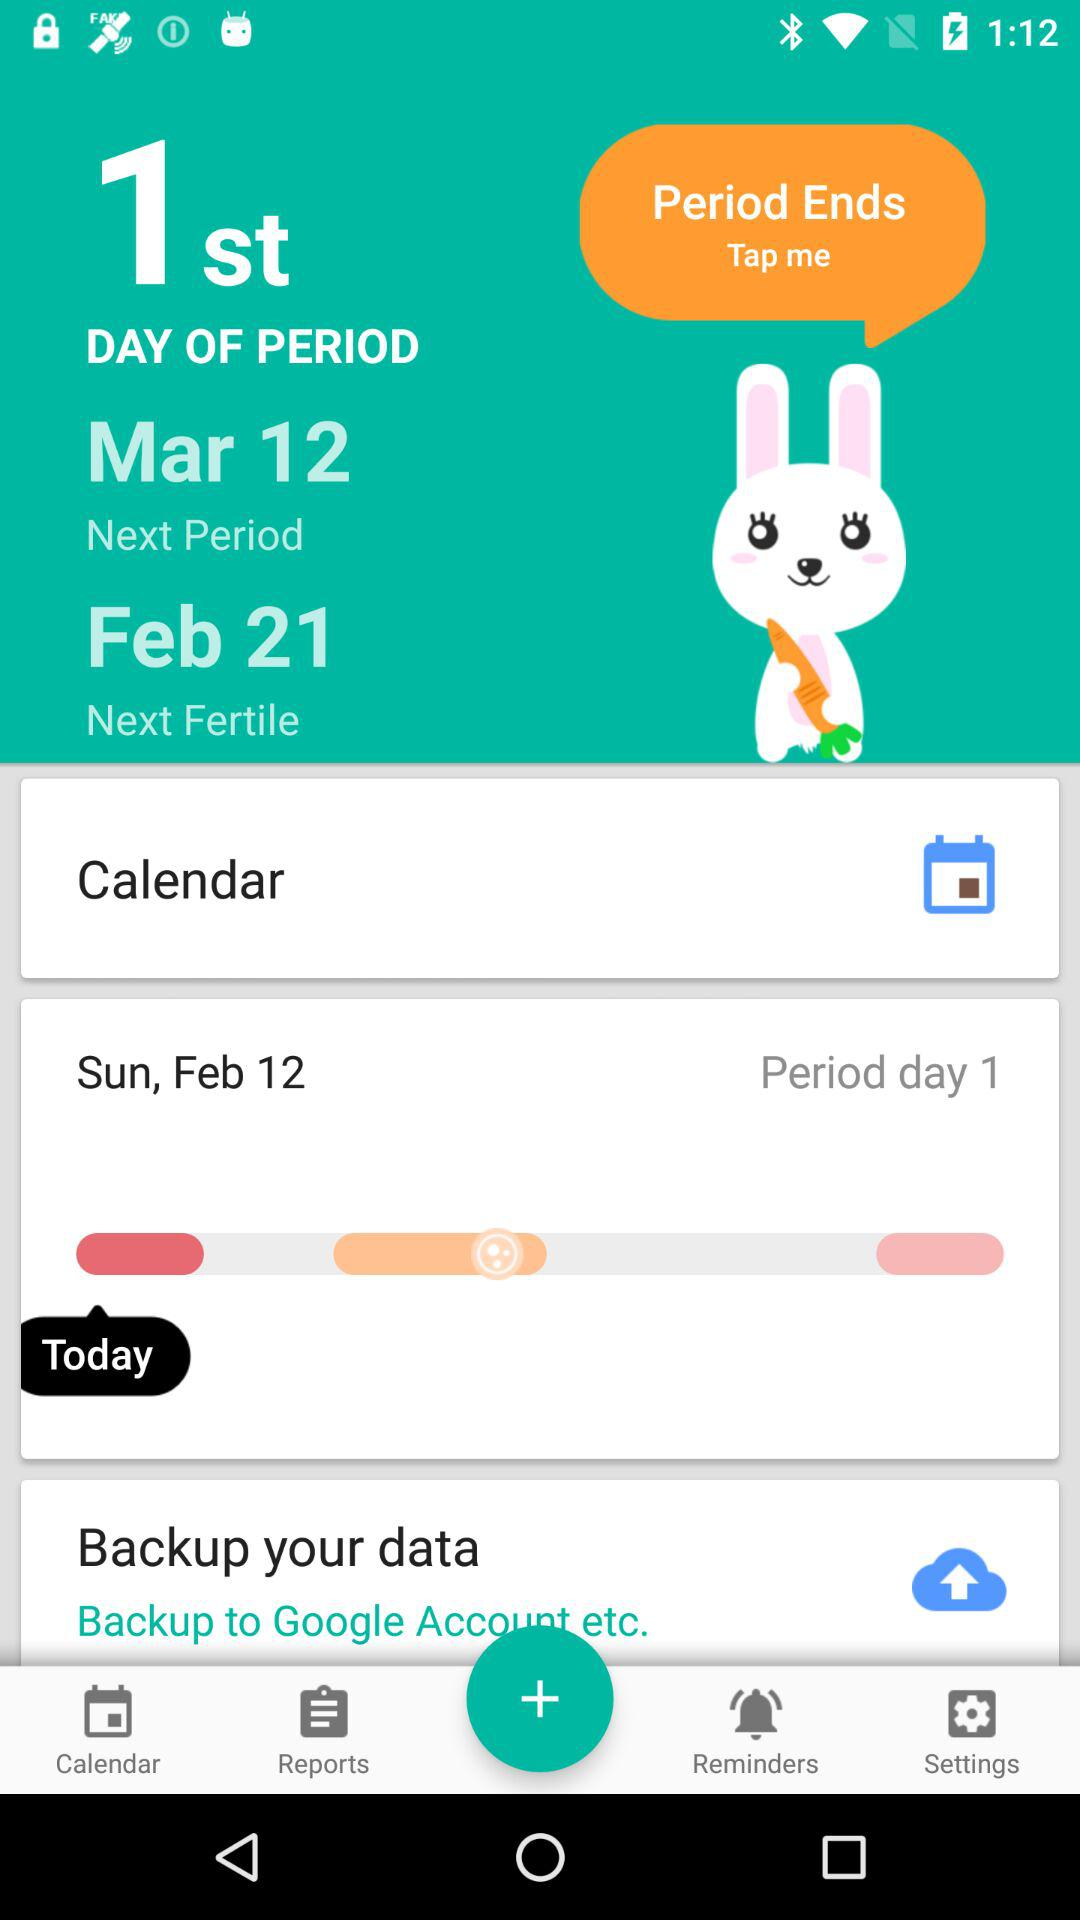Which days of the week are selected to get a reminder?
When the provided information is insufficient, respond with <no answer>. <no answer> 